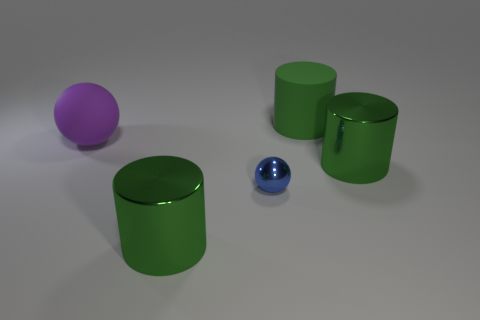Subtract all green rubber cylinders. How many cylinders are left? 2 Add 4 metal balls. How many objects exist? 9 Subtract all blue balls. How many balls are left? 1 Subtract all balls. How many objects are left? 3 Subtract 2 cylinders. How many cylinders are left? 1 Add 5 large green metal things. How many large green metal things are left? 7 Add 3 big things. How many big things exist? 7 Subtract 0 red cubes. How many objects are left? 5 Subtract all cyan spheres. Subtract all blue blocks. How many spheres are left? 2 Subtract all cyan rubber balls. Subtract all big shiny things. How many objects are left? 3 